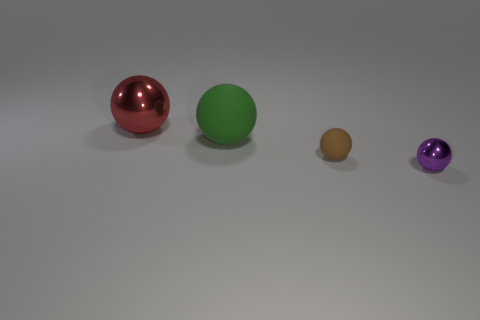There is a brown rubber thing; is its shape the same as the shiny thing that is in front of the large red metal thing?
Offer a terse response. Yes. Is the number of metal spheres that are on the right side of the red metallic ball greater than the number of large blue balls?
Keep it short and to the point. Yes. Is the number of small purple metallic spheres left of the large rubber sphere less than the number of matte spheres?
Your answer should be compact. Yes. How many purple objects are either large things or matte things?
Make the answer very short. 0. Are there fewer tiny purple metallic spheres that are behind the small purple metallic thing than things that are in front of the green rubber ball?
Your response must be concise. Yes. Is there another object of the same size as the green object?
Offer a very short reply. Yes. There is a shiny ball behind the purple object; is it the same size as the brown ball?
Provide a succinct answer. No. Are there more big red metal objects than blocks?
Keep it short and to the point. Yes. Is there a purple shiny thing of the same shape as the large green rubber thing?
Provide a succinct answer. Yes. What is the shape of the tiny object that is left of the tiny purple thing?
Your answer should be very brief. Sphere. 